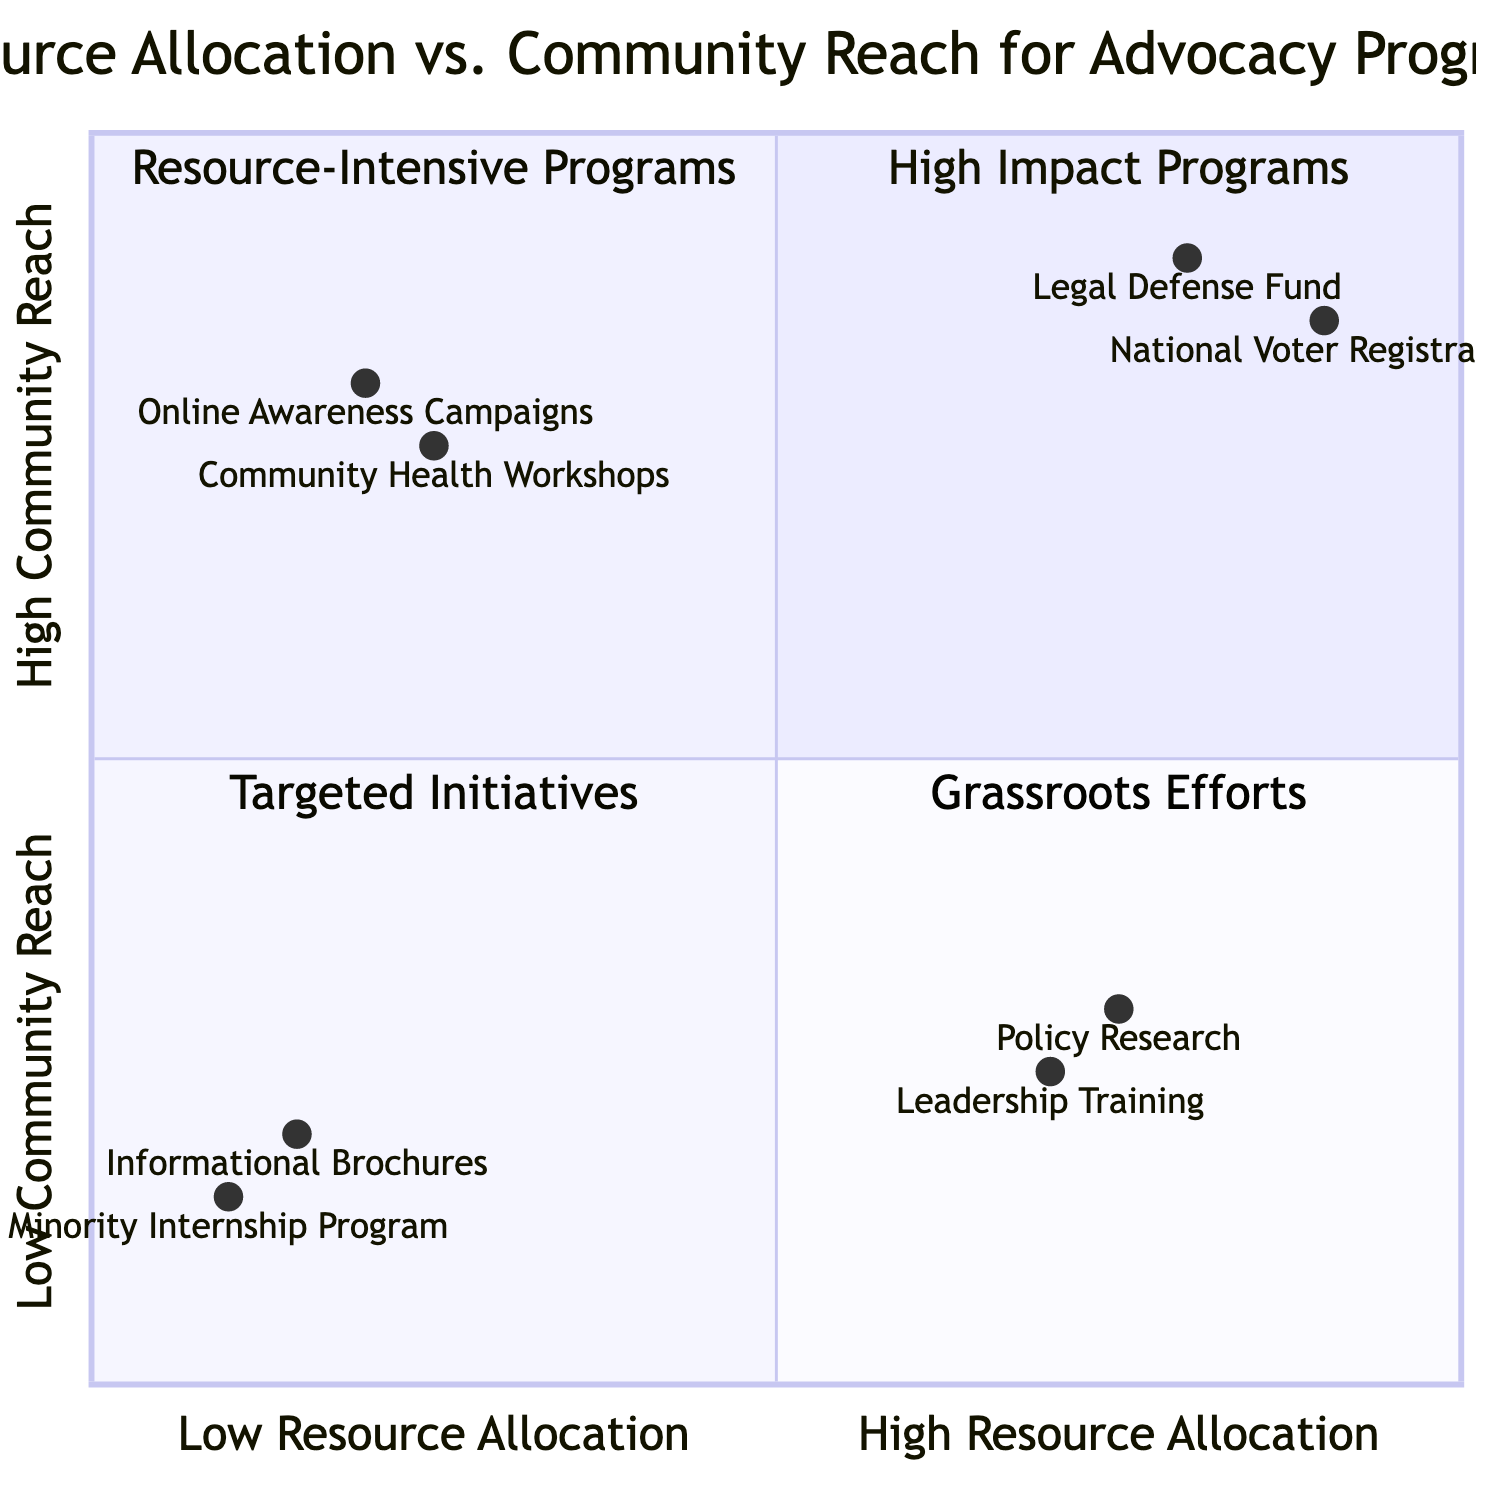What program is located in the High Resource Allocation / High Community Reach quadrant? The High Resource Allocation / High Community Reach quadrant contains programs that effectively utilize significant resources while also reaching a large community. The "Legal Defense Fund" and "National Voter Registration Campaign" are both examples in that quadrant. Therefore, one program is "Legal Defense Fund".
Answer: Legal Defense Fund How many programs are in the Low Resource Allocation / Low Community Reach quadrant? By identifying the programs that belong to the Low Resource Allocation / Low Community Reach quadrant, we see there are two programs listed: "Informational Brochures" and "Minority Internship Program". Thus, we count these to find there are two programs.
Answer: 2 Which program has the highest community reach in the Low Resource Allocation / High Community Reach quadrant? Looking at the Low Resource Allocation / High Community Reach quadrant, we survey the community reach values. The "Online Awareness Campaigns" has a value of 0.8, while "Community Health Workshops" has a value of 0.75. Therefore, "Online Awareness Campaigns" holds the highest community reach in that quadrant.
Answer: Online Awareness Campaigns Which quadrant contains resource-intensive programs? The phrase 'resource-intensive programs' refers to those that allocate substantial resources, which points us towards the quadrants with high resource allocation. By examining the diagram, the "High Resource Allocation / Low Community Reach" quadrant contains programs like "Policy Research and Development" and "Leadership Training Programs", both of which are resource-intensive.
Answer: High Resource Allocation / Low Community Reach What is the community reach value of the "Leadership Training Programs"? The "Leadership Training Programs" are located in the High Resource Allocation / Low Community Reach quadrant, and upon inspecting the value given in the diagram, we find its community reach value is 0.25.
Answer: 0.25 Which category does "Community Health Workshops" fall under? To categorize "Community Health Workshops," we locate it within the diagram. This program is situated in the Low Resource Allocation / High Community Reach quadrant. This categorization shows it works effectively with minimal resources but affects a considerable portion of the community.
Answer: Low Resource Allocation / High Community Reach What is the relationship between resource allocation and the reach of "Informational Brochures"? "Informational Brochures" is positioned in the Low Resource Allocation / Low Community Reach quadrant. This indicates a very limited engagement with the community, directly correlating to its low resource allocation. Hence, both resource allocation and community reach are at their lowest for this program.
Answer: Low Resource Allocation / Low Community Reach 